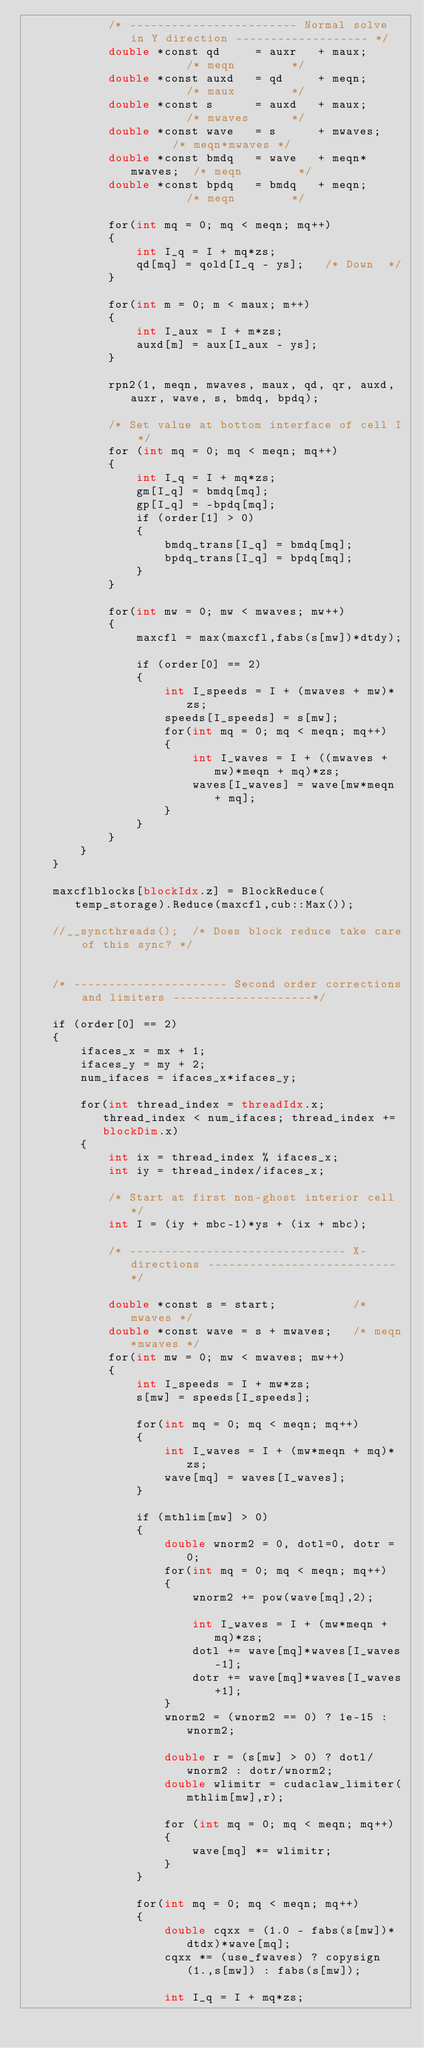<code> <loc_0><loc_0><loc_500><loc_500><_Cuda_>            /* ------------------------ Normal solve in Y direction ------------------- */
            double *const qd     = auxr   + maux;         /* meqn        */
            double *const auxd   = qd     + meqn;         /* maux        */
            double *const s      = auxd   + maux;         /* mwaves      */
            double *const wave   = s      + mwaves;       /* meqn*mwaves */
            double *const bmdq   = wave   + meqn*mwaves;  /* meqn        */
            double *const bpdq   = bmdq   + meqn;         /* meqn        */

            for(int mq = 0; mq < meqn; mq++)
            {
                int I_q = I + mq*zs;
                qd[mq] = qold[I_q - ys];   /* Down  */  
            }

            for(int m = 0; m < maux; m++)
            {
                int I_aux = I + m*zs;
                auxd[m] = aux[I_aux - ys];
            }               

            rpn2(1, meqn, mwaves, maux, qd, qr, auxd, auxr, wave, s, bmdq, bpdq);

            /* Set value at bottom interface of cell I */
            for (int mq = 0; mq < meqn; mq++) 
            {
                int I_q = I + mq*zs;
                gm[I_q] = bmdq[mq];
                gp[I_q] = -bpdq[mq]; 
                if (order[1] > 0)
                {
                    bmdq_trans[I_q] = bmdq[mq];                                                   
                    bpdq_trans[I_q] = bpdq[mq];
                }
            }

            for(int mw = 0; mw < mwaves; mw++)
            {
                maxcfl = max(maxcfl,fabs(s[mw])*dtdy);

                if (order[0] == 2)
                {                    
                    int I_speeds = I + (mwaves + mw)*zs;
                    speeds[I_speeds] = s[mw];
                    for(int mq = 0; mq < meqn; mq++)
                    {
                        int I_waves = I + ((mwaves + mw)*meqn + mq)*zs;
                        waves[I_waves] = wave[mw*meqn + mq];
                    }
                }
            }
        }
    }

    maxcflblocks[blockIdx.z] = BlockReduce(temp_storage).Reduce(maxcfl,cub::Max());

    //__syncthreads();  /* Does block reduce take care of this sync? */


    /* ---------------------- Second order corrections and limiters --------------------*/  

    if (order[0] == 2)
    {
        ifaces_x = mx + 1;  
        ifaces_y = my + 2;
        num_ifaces = ifaces_x*ifaces_y;

        for(int thread_index = threadIdx.x; thread_index < num_ifaces; thread_index += blockDim.x)
        { 
            int ix = thread_index % ifaces_x;
            int iy = thread_index/ifaces_x;

            /* Start at first non-ghost interior cell */
            int I = (iy + mbc-1)*ys + (ix + mbc);

            /* ------------------------------- X-directions --------------------------- */

            double *const s = start;           /* mwaves */
            double *const wave = s + mwaves;   /* meqn*mwaves */
            for(int mw = 0; mw < mwaves; mw++)
            {                
                int I_speeds = I + mw*zs;
                s[mw] = speeds[I_speeds];

                for(int mq = 0; mq < meqn; mq++)
                {
                    int I_waves = I + (mw*meqn + mq)*zs;
                    wave[mq] = waves[I_waves];
                }                        

                if (mthlim[mw] > 0)
                {
                    double wnorm2 = 0, dotl=0, dotr = 0;
                    for(int mq = 0; mq < meqn; mq++)
                    {
                        wnorm2 += pow(wave[mq],2);

                        int I_waves = I + (mw*meqn + mq)*zs;
                        dotl += wave[mq]*waves[I_waves-1];
                        dotr += wave[mq]*waves[I_waves+1];
                    }
                    wnorm2 = (wnorm2 == 0) ? 1e-15 : wnorm2;
                                               
                    double r = (s[mw] > 0) ? dotl/wnorm2 : dotr/wnorm2;
                    double wlimitr = cudaclaw_limiter(mthlim[mw],r);  

                    for (int mq = 0; mq < meqn; mq++)
                    {
                        wave[mq] *= wlimitr;
                    }                    
                }

                for(int mq = 0; mq < meqn; mq++)
                {
                    double cqxx = (1.0 - fabs(s[mw])*dtdx)*wave[mq];
                    cqxx *= (use_fwaves) ? copysign(1.,s[mw]) : fabs(s[mw]);

                    int I_q = I + mq*zs;</code> 